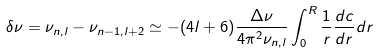Convert formula to latex. <formula><loc_0><loc_0><loc_500><loc_500>\delta \nu = \nu _ { n , l } - \nu _ { n - 1 , l + 2 } \simeq - ( 4 l + 6 ) \frac { \Delta \nu } { 4 \pi ^ { 2 } \nu _ { n , l } } \int _ { 0 } ^ { R } \frac { 1 } { r } \frac { d c } { d r } d r</formula> 